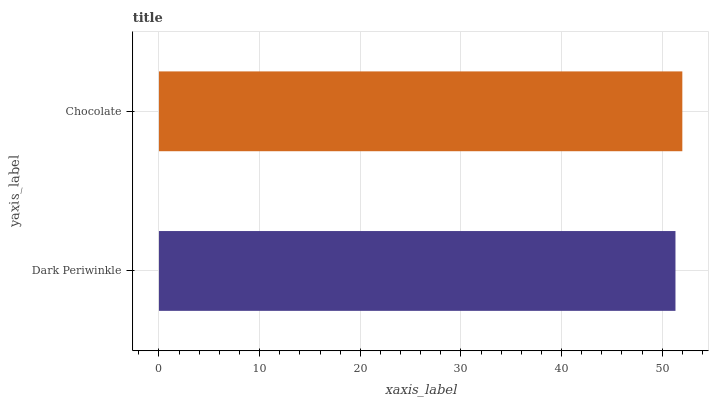Is Dark Periwinkle the minimum?
Answer yes or no. Yes. Is Chocolate the maximum?
Answer yes or no. Yes. Is Chocolate the minimum?
Answer yes or no. No. Is Chocolate greater than Dark Periwinkle?
Answer yes or no. Yes. Is Dark Periwinkle less than Chocolate?
Answer yes or no. Yes. Is Dark Periwinkle greater than Chocolate?
Answer yes or no. No. Is Chocolate less than Dark Periwinkle?
Answer yes or no. No. Is Chocolate the high median?
Answer yes or no. Yes. Is Dark Periwinkle the low median?
Answer yes or no. Yes. Is Dark Periwinkle the high median?
Answer yes or no. No. Is Chocolate the low median?
Answer yes or no. No. 